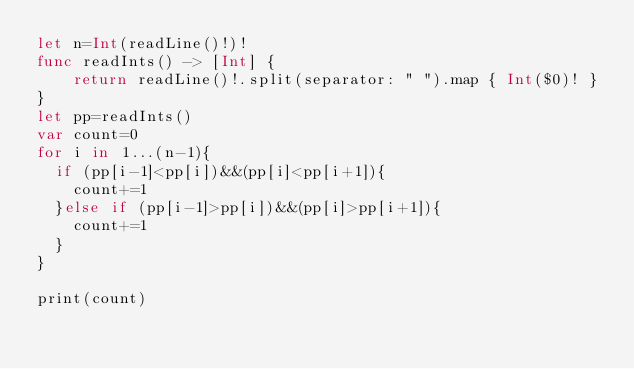Convert code to text. <code><loc_0><loc_0><loc_500><loc_500><_Swift_>let n=Int(readLine()!)!
func readInts() -> [Int] {
    return readLine()!.split(separator: " ").map { Int($0)! }
}
let pp=readInts()
var count=0
for i in 1...(n-1){
  if (pp[i-1]<pp[i])&&(pp[i]<pp[i+1]){
    count+=1
  }else if (pp[i-1]>pp[i])&&(pp[i]>pp[i+1]){
    count+=1
  }
}

print(count)

</code> 